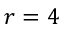Convert formula to latex. <formula><loc_0><loc_0><loc_500><loc_500>r = 4</formula> 